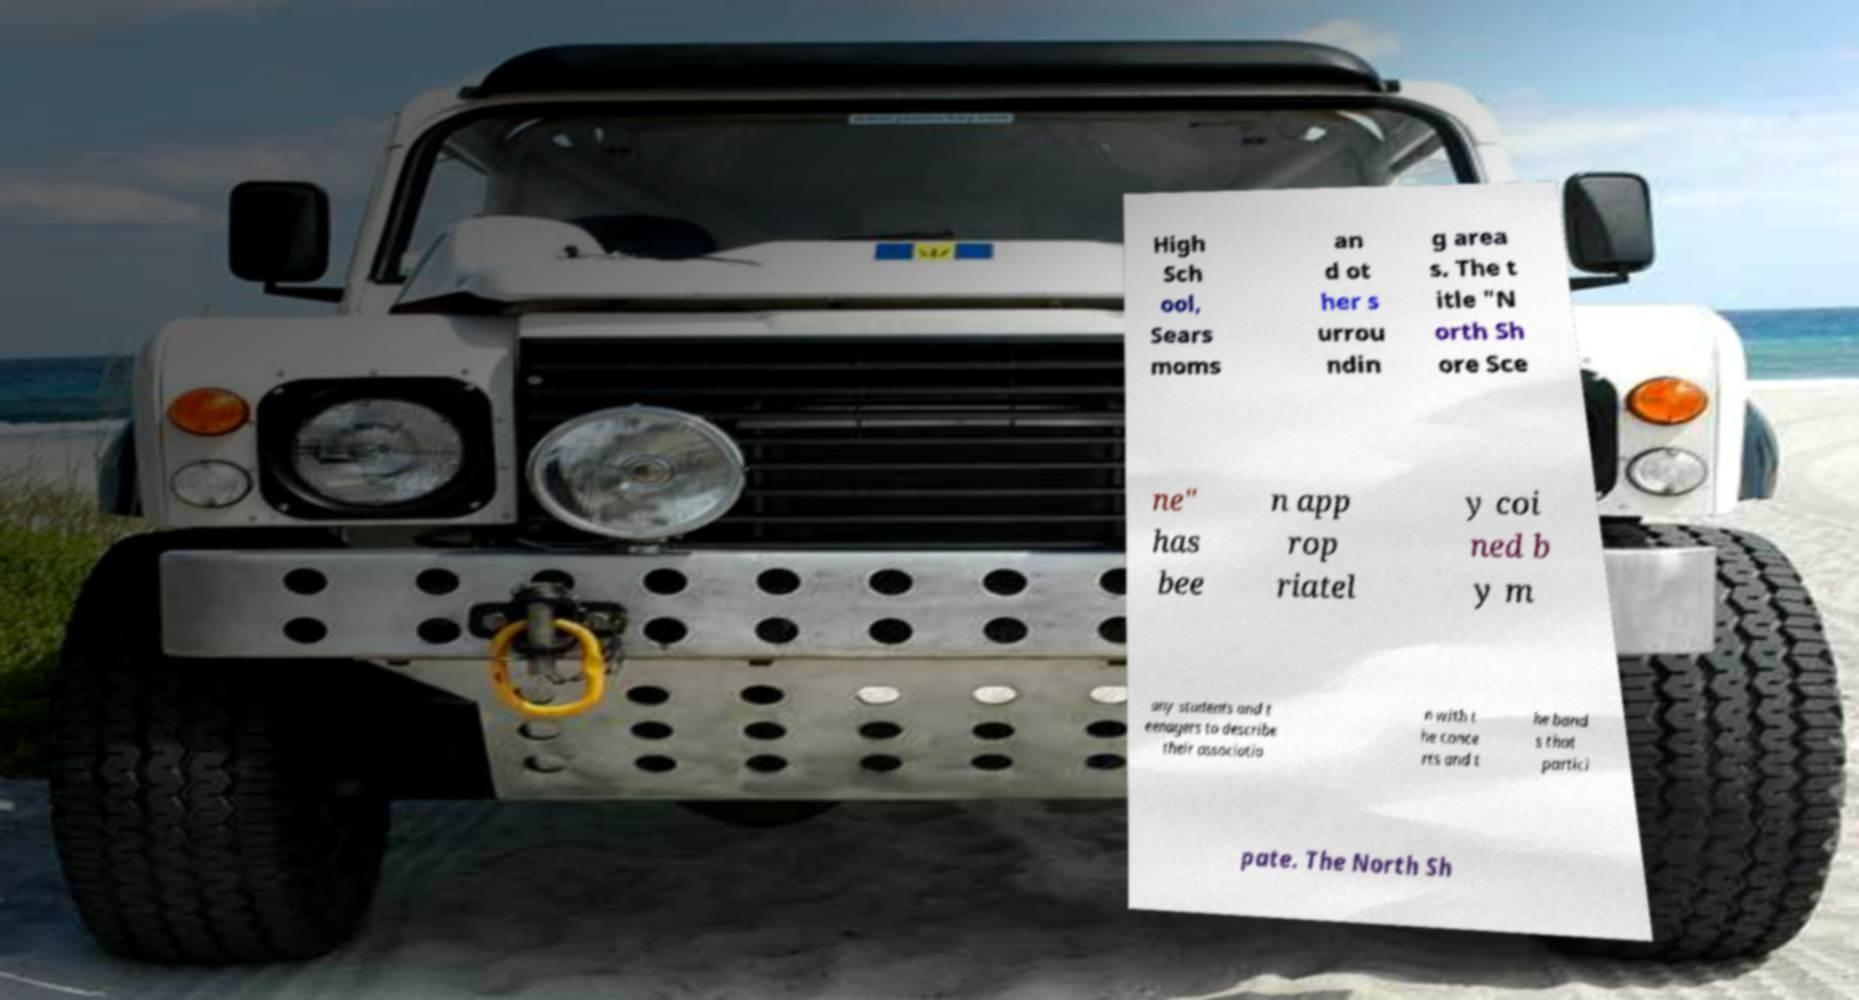Can you accurately transcribe the text from the provided image for me? High Sch ool, Sears moms an d ot her s urrou ndin g area s. The t itle "N orth Sh ore Sce ne" has bee n app rop riatel y coi ned b y m any students and t eenagers to describe their associatio n with t he conce rts and t he band s that partici pate. The North Sh 